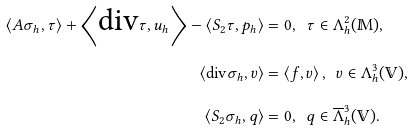<formula> <loc_0><loc_0><loc_500><loc_500>\left \langle A \sigma _ { h } , \tau \right \rangle + \left \langle \text {div} \tau , u _ { h } \right \rangle - \left \langle S _ { 2 } \tau , p _ { h } \right \rangle & = 0 , \text { \ } \tau \in \Lambda _ { h } ^ { 2 } ( \mathbb { M } ) , \\ \left \langle \text {div} \sigma _ { h } , v \right \rangle & = \left \langle f , v \right \rangle , \text { \ } v \in \Lambda _ { h } ^ { 3 } ( \mathbb { V } ) , \\ \left \langle S _ { 2 } \sigma _ { h } , q \right \rangle & = 0 , \text { \ } q \in \overline { \Lambda } _ { h } ^ { 3 } ( \mathbb { V } ) .</formula> 